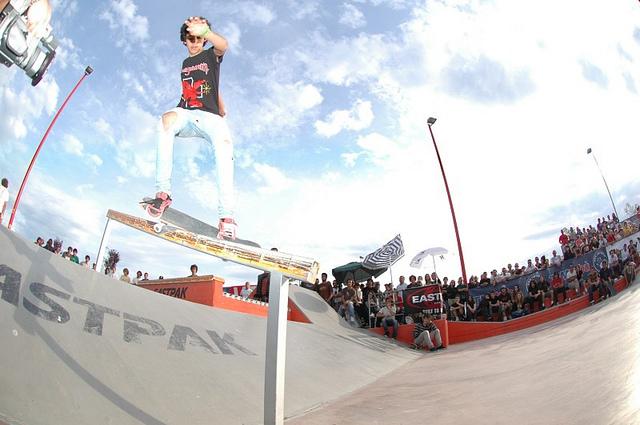Is this a competition?
Quick response, please. Yes. What are the people observing?
Write a very short answer. Skateboarder. Are there any clouds in the sky?
Quick response, please. Yes. 